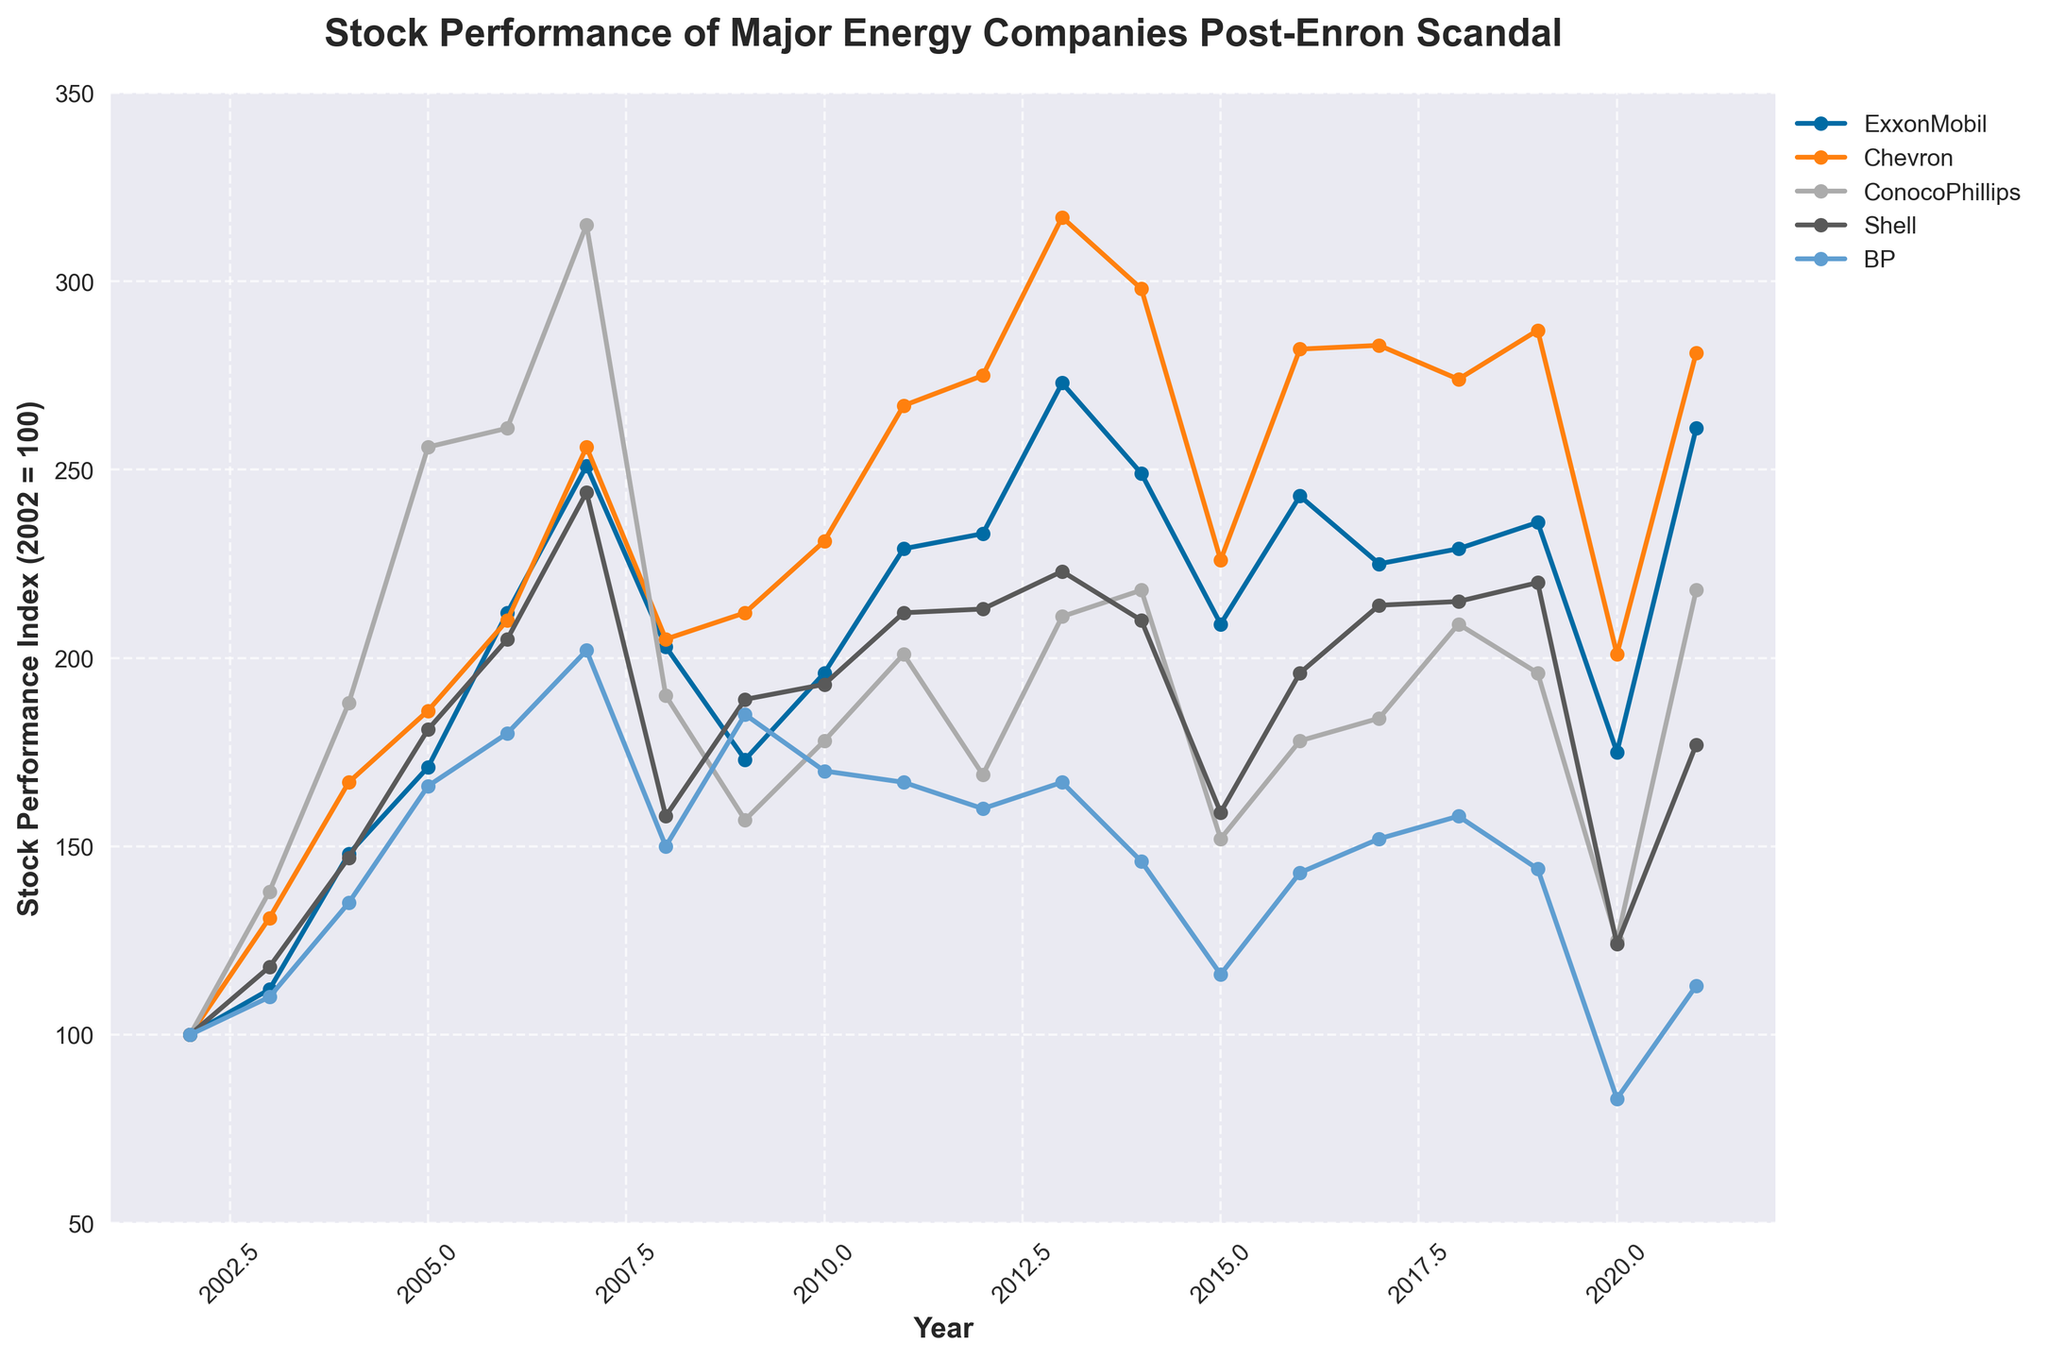Which company had the highest stock performance in 2007? According to the chart, we can see the line representing ConocoPhillips is the highest value in 2007.
Answer: ConocoPhillips What was the difference in stock performance between ExxonMobil and BP in 2020? The chart shows ExxonMobil at 175 and BP at 83. The difference is 175 - 83 = 92.
Answer: 92 Looking at the trend lines, which company showed the greatest recovery from 2008 to 2011? By examining the lines, all lines show a drop in 2008, but ConocoPhillips made the most significant jump from 157 in 2009 to 201 in 2011, thus the greatest recovery.
Answer: ConocoPhillips What is the average stock performance of Shell from 2017 to 2021? The values for Shell from 2017 to 2021 are 214, 215, 220, 124, and 177. Their sum is 950, and the average is 950/5 = 190.
Answer: 190 Which company had the lowest stock performance in 2015? Based on the chart, BP had the lowest value, which was around 116, in 2015.
Answer: BP Compare the stock performance of Chevron and ExxonMobil in 2006. Which one was higher, and by how much? In 2006, Chevron had a value of 210, and ExxonMobil had a value of 212. ExxonMobil's performance was higher by 212 - 210 = 2.
Answer: ExxonMobil, by 2 During which year did ConocoPhillips experience the most significant decline compared to its highest peak? ConocoPhillips experienced a significant drop from its peak of 315 in 2007 to 190 in 2008. The most significant decline happened in 2008.
Answer: 2008 Which company had the shortest interval between its highest peak and lowest dip post-2007? By checking the highs and lows post-2007, especially around 2008 and the subsequent years, BP's performance had the shortest interval between 2021 (113) and 2007 (202), given no dramatic peaks like the others.
Answer: BP 